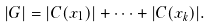Convert formula to latex. <formula><loc_0><loc_0><loc_500><loc_500>| G | = | C ( x _ { 1 } ) | + \cdots + | C ( x _ { k } ) | .</formula> 